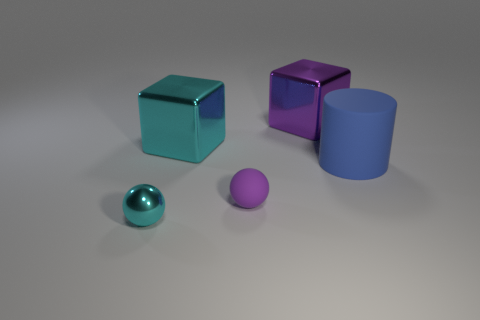Subtract all green blocks. Subtract all green cylinders. How many blocks are left? 2 Add 5 purple blocks. How many objects exist? 10 Subtract all blocks. How many objects are left? 3 Subtract 0 red cubes. How many objects are left? 5 Subtract all big red metallic blocks. Subtract all tiny things. How many objects are left? 3 Add 3 purple cubes. How many purple cubes are left? 4 Add 2 large gray rubber spheres. How many large gray rubber spheres exist? 2 